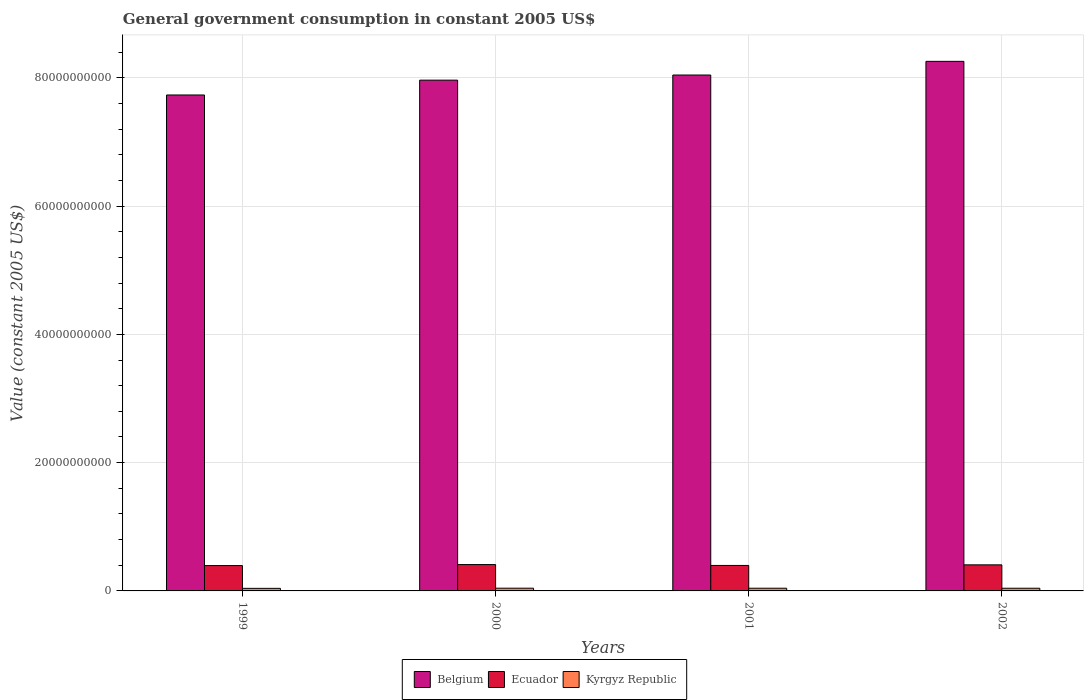How many bars are there on the 1st tick from the left?
Your response must be concise. 3. What is the label of the 2nd group of bars from the left?
Your answer should be very brief. 2000. In how many cases, is the number of bars for a given year not equal to the number of legend labels?
Offer a very short reply. 0. What is the government conusmption in Belgium in 2002?
Provide a short and direct response. 8.26e+1. Across all years, what is the maximum government conusmption in Ecuador?
Keep it short and to the point. 4.11e+09. Across all years, what is the minimum government conusmption in Belgium?
Keep it short and to the point. 7.73e+1. In which year was the government conusmption in Kyrgyz Republic minimum?
Make the answer very short. 1999. What is the total government conusmption in Belgium in the graph?
Provide a succinct answer. 3.20e+11. What is the difference between the government conusmption in Ecuador in 2000 and that in 2002?
Provide a short and direct response. 4.27e+07. What is the difference between the government conusmption in Ecuador in 2000 and the government conusmption in Kyrgyz Republic in 1999?
Give a very brief answer. 3.71e+09. What is the average government conusmption in Belgium per year?
Your answer should be very brief. 8.00e+1. In the year 2000, what is the difference between the government conusmption in Belgium and government conusmption in Ecuador?
Ensure brevity in your answer.  7.55e+1. In how many years, is the government conusmption in Belgium greater than 28000000000 US$?
Your answer should be very brief. 4. What is the ratio of the government conusmption in Belgium in 1999 to that in 2000?
Keep it short and to the point. 0.97. What is the difference between the highest and the second highest government conusmption in Belgium?
Offer a very short reply. 2.13e+09. What is the difference between the highest and the lowest government conusmption in Ecuador?
Your answer should be compact. 1.58e+08. What does the 3rd bar from the left in 1999 represents?
Give a very brief answer. Kyrgyz Republic. What does the 1st bar from the right in 2001 represents?
Provide a short and direct response. Kyrgyz Republic. How many years are there in the graph?
Ensure brevity in your answer.  4. Are the values on the major ticks of Y-axis written in scientific E-notation?
Make the answer very short. No. Does the graph contain any zero values?
Your response must be concise. No. Does the graph contain grids?
Give a very brief answer. Yes. Where does the legend appear in the graph?
Make the answer very short. Bottom center. How many legend labels are there?
Provide a short and direct response. 3. How are the legend labels stacked?
Give a very brief answer. Horizontal. What is the title of the graph?
Your answer should be compact. General government consumption in constant 2005 US$. Does "Heavily indebted poor countries" appear as one of the legend labels in the graph?
Your response must be concise. No. What is the label or title of the Y-axis?
Offer a very short reply. Value (constant 2005 US$). What is the Value (constant 2005 US$) in Belgium in 1999?
Ensure brevity in your answer.  7.73e+1. What is the Value (constant 2005 US$) of Ecuador in 1999?
Offer a very short reply. 3.95e+09. What is the Value (constant 2005 US$) in Kyrgyz Republic in 1999?
Give a very brief answer. 4.01e+08. What is the Value (constant 2005 US$) of Belgium in 2000?
Give a very brief answer. 7.96e+1. What is the Value (constant 2005 US$) in Ecuador in 2000?
Ensure brevity in your answer.  4.11e+09. What is the Value (constant 2005 US$) of Kyrgyz Republic in 2000?
Give a very brief answer. 4.25e+08. What is the Value (constant 2005 US$) of Belgium in 2001?
Your answer should be compact. 8.04e+1. What is the Value (constant 2005 US$) of Ecuador in 2001?
Provide a short and direct response. 3.97e+09. What is the Value (constant 2005 US$) in Kyrgyz Republic in 2001?
Make the answer very short. 4.19e+08. What is the Value (constant 2005 US$) in Belgium in 2002?
Your response must be concise. 8.26e+1. What is the Value (constant 2005 US$) of Ecuador in 2002?
Your answer should be compact. 4.07e+09. What is the Value (constant 2005 US$) of Kyrgyz Republic in 2002?
Provide a short and direct response. 4.18e+08. Across all years, what is the maximum Value (constant 2005 US$) of Belgium?
Your response must be concise. 8.26e+1. Across all years, what is the maximum Value (constant 2005 US$) in Ecuador?
Your response must be concise. 4.11e+09. Across all years, what is the maximum Value (constant 2005 US$) in Kyrgyz Republic?
Give a very brief answer. 4.25e+08. Across all years, what is the minimum Value (constant 2005 US$) of Belgium?
Offer a terse response. 7.73e+1. Across all years, what is the minimum Value (constant 2005 US$) of Ecuador?
Your answer should be compact. 3.95e+09. Across all years, what is the minimum Value (constant 2005 US$) of Kyrgyz Republic?
Provide a short and direct response. 4.01e+08. What is the total Value (constant 2005 US$) in Belgium in the graph?
Offer a very short reply. 3.20e+11. What is the total Value (constant 2005 US$) in Ecuador in the graph?
Your response must be concise. 1.61e+1. What is the total Value (constant 2005 US$) of Kyrgyz Republic in the graph?
Offer a very short reply. 1.66e+09. What is the difference between the Value (constant 2005 US$) in Belgium in 1999 and that in 2000?
Make the answer very short. -2.31e+09. What is the difference between the Value (constant 2005 US$) in Ecuador in 1999 and that in 2000?
Give a very brief answer. -1.58e+08. What is the difference between the Value (constant 2005 US$) in Kyrgyz Republic in 1999 and that in 2000?
Give a very brief answer. -2.38e+07. What is the difference between the Value (constant 2005 US$) of Belgium in 1999 and that in 2001?
Your response must be concise. -3.11e+09. What is the difference between the Value (constant 2005 US$) of Ecuador in 1999 and that in 2001?
Keep it short and to the point. -2.16e+07. What is the difference between the Value (constant 2005 US$) in Kyrgyz Republic in 1999 and that in 2001?
Provide a succinct answer. -1.84e+07. What is the difference between the Value (constant 2005 US$) in Belgium in 1999 and that in 2002?
Keep it short and to the point. -5.24e+09. What is the difference between the Value (constant 2005 US$) in Ecuador in 1999 and that in 2002?
Offer a terse response. -1.15e+08. What is the difference between the Value (constant 2005 US$) of Kyrgyz Republic in 1999 and that in 2002?
Provide a short and direct response. -1.74e+07. What is the difference between the Value (constant 2005 US$) of Belgium in 2000 and that in 2001?
Ensure brevity in your answer.  -8.00e+08. What is the difference between the Value (constant 2005 US$) in Ecuador in 2000 and that in 2001?
Your response must be concise. 1.37e+08. What is the difference between the Value (constant 2005 US$) in Kyrgyz Republic in 2000 and that in 2001?
Offer a very short reply. 5.42e+06. What is the difference between the Value (constant 2005 US$) of Belgium in 2000 and that in 2002?
Your response must be concise. -2.93e+09. What is the difference between the Value (constant 2005 US$) of Ecuador in 2000 and that in 2002?
Provide a succinct answer. 4.27e+07. What is the difference between the Value (constant 2005 US$) of Kyrgyz Republic in 2000 and that in 2002?
Give a very brief answer. 6.35e+06. What is the difference between the Value (constant 2005 US$) of Belgium in 2001 and that in 2002?
Make the answer very short. -2.13e+09. What is the difference between the Value (constant 2005 US$) in Ecuador in 2001 and that in 2002?
Offer a terse response. -9.39e+07. What is the difference between the Value (constant 2005 US$) in Kyrgyz Republic in 2001 and that in 2002?
Your answer should be compact. 9.29e+05. What is the difference between the Value (constant 2005 US$) of Belgium in 1999 and the Value (constant 2005 US$) of Ecuador in 2000?
Make the answer very short. 7.32e+1. What is the difference between the Value (constant 2005 US$) of Belgium in 1999 and the Value (constant 2005 US$) of Kyrgyz Republic in 2000?
Keep it short and to the point. 7.69e+1. What is the difference between the Value (constant 2005 US$) in Ecuador in 1999 and the Value (constant 2005 US$) in Kyrgyz Republic in 2000?
Provide a short and direct response. 3.52e+09. What is the difference between the Value (constant 2005 US$) of Belgium in 1999 and the Value (constant 2005 US$) of Ecuador in 2001?
Provide a short and direct response. 7.34e+1. What is the difference between the Value (constant 2005 US$) of Belgium in 1999 and the Value (constant 2005 US$) of Kyrgyz Republic in 2001?
Offer a very short reply. 7.69e+1. What is the difference between the Value (constant 2005 US$) in Ecuador in 1999 and the Value (constant 2005 US$) in Kyrgyz Republic in 2001?
Offer a terse response. 3.53e+09. What is the difference between the Value (constant 2005 US$) in Belgium in 1999 and the Value (constant 2005 US$) in Ecuador in 2002?
Provide a succinct answer. 7.33e+1. What is the difference between the Value (constant 2005 US$) of Belgium in 1999 and the Value (constant 2005 US$) of Kyrgyz Republic in 2002?
Your answer should be compact. 7.69e+1. What is the difference between the Value (constant 2005 US$) in Ecuador in 1999 and the Value (constant 2005 US$) in Kyrgyz Republic in 2002?
Your response must be concise. 3.53e+09. What is the difference between the Value (constant 2005 US$) in Belgium in 2000 and the Value (constant 2005 US$) in Ecuador in 2001?
Your answer should be very brief. 7.57e+1. What is the difference between the Value (constant 2005 US$) of Belgium in 2000 and the Value (constant 2005 US$) of Kyrgyz Republic in 2001?
Give a very brief answer. 7.92e+1. What is the difference between the Value (constant 2005 US$) of Ecuador in 2000 and the Value (constant 2005 US$) of Kyrgyz Republic in 2001?
Your answer should be compact. 3.69e+09. What is the difference between the Value (constant 2005 US$) of Belgium in 2000 and the Value (constant 2005 US$) of Ecuador in 2002?
Your response must be concise. 7.56e+1. What is the difference between the Value (constant 2005 US$) in Belgium in 2000 and the Value (constant 2005 US$) in Kyrgyz Republic in 2002?
Offer a very short reply. 7.92e+1. What is the difference between the Value (constant 2005 US$) of Ecuador in 2000 and the Value (constant 2005 US$) of Kyrgyz Republic in 2002?
Provide a succinct answer. 3.69e+09. What is the difference between the Value (constant 2005 US$) of Belgium in 2001 and the Value (constant 2005 US$) of Ecuador in 2002?
Keep it short and to the point. 7.64e+1. What is the difference between the Value (constant 2005 US$) of Belgium in 2001 and the Value (constant 2005 US$) of Kyrgyz Republic in 2002?
Make the answer very short. 8.00e+1. What is the difference between the Value (constant 2005 US$) of Ecuador in 2001 and the Value (constant 2005 US$) of Kyrgyz Republic in 2002?
Your answer should be very brief. 3.55e+09. What is the average Value (constant 2005 US$) of Belgium per year?
Your answer should be very brief. 8.00e+1. What is the average Value (constant 2005 US$) of Ecuador per year?
Provide a succinct answer. 4.02e+09. What is the average Value (constant 2005 US$) of Kyrgyz Republic per year?
Keep it short and to the point. 4.16e+08. In the year 1999, what is the difference between the Value (constant 2005 US$) of Belgium and Value (constant 2005 US$) of Ecuador?
Offer a very short reply. 7.34e+1. In the year 1999, what is the difference between the Value (constant 2005 US$) of Belgium and Value (constant 2005 US$) of Kyrgyz Republic?
Ensure brevity in your answer.  7.69e+1. In the year 1999, what is the difference between the Value (constant 2005 US$) in Ecuador and Value (constant 2005 US$) in Kyrgyz Republic?
Give a very brief answer. 3.55e+09. In the year 2000, what is the difference between the Value (constant 2005 US$) in Belgium and Value (constant 2005 US$) in Ecuador?
Your answer should be very brief. 7.55e+1. In the year 2000, what is the difference between the Value (constant 2005 US$) of Belgium and Value (constant 2005 US$) of Kyrgyz Republic?
Offer a very short reply. 7.92e+1. In the year 2000, what is the difference between the Value (constant 2005 US$) of Ecuador and Value (constant 2005 US$) of Kyrgyz Republic?
Ensure brevity in your answer.  3.68e+09. In the year 2001, what is the difference between the Value (constant 2005 US$) of Belgium and Value (constant 2005 US$) of Ecuador?
Provide a short and direct response. 7.65e+1. In the year 2001, what is the difference between the Value (constant 2005 US$) of Belgium and Value (constant 2005 US$) of Kyrgyz Republic?
Offer a very short reply. 8.00e+1. In the year 2001, what is the difference between the Value (constant 2005 US$) of Ecuador and Value (constant 2005 US$) of Kyrgyz Republic?
Ensure brevity in your answer.  3.55e+09. In the year 2002, what is the difference between the Value (constant 2005 US$) in Belgium and Value (constant 2005 US$) in Ecuador?
Provide a succinct answer. 7.85e+1. In the year 2002, what is the difference between the Value (constant 2005 US$) in Belgium and Value (constant 2005 US$) in Kyrgyz Republic?
Offer a terse response. 8.21e+1. In the year 2002, what is the difference between the Value (constant 2005 US$) of Ecuador and Value (constant 2005 US$) of Kyrgyz Republic?
Your response must be concise. 3.65e+09. What is the ratio of the Value (constant 2005 US$) in Belgium in 1999 to that in 2000?
Your answer should be very brief. 0.97. What is the ratio of the Value (constant 2005 US$) of Ecuador in 1999 to that in 2000?
Offer a terse response. 0.96. What is the ratio of the Value (constant 2005 US$) in Kyrgyz Republic in 1999 to that in 2000?
Offer a terse response. 0.94. What is the ratio of the Value (constant 2005 US$) of Belgium in 1999 to that in 2001?
Keep it short and to the point. 0.96. What is the ratio of the Value (constant 2005 US$) of Kyrgyz Republic in 1999 to that in 2001?
Give a very brief answer. 0.96. What is the ratio of the Value (constant 2005 US$) of Belgium in 1999 to that in 2002?
Ensure brevity in your answer.  0.94. What is the ratio of the Value (constant 2005 US$) of Ecuador in 1999 to that in 2002?
Your answer should be very brief. 0.97. What is the ratio of the Value (constant 2005 US$) of Kyrgyz Republic in 1999 to that in 2002?
Provide a succinct answer. 0.96. What is the ratio of the Value (constant 2005 US$) of Ecuador in 2000 to that in 2001?
Ensure brevity in your answer.  1.03. What is the ratio of the Value (constant 2005 US$) of Kyrgyz Republic in 2000 to that in 2001?
Give a very brief answer. 1.01. What is the ratio of the Value (constant 2005 US$) in Belgium in 2000 to that in 2002?
Give a very brief answer. 0.96. What is the ratio of the Value (constant 2005 US$) in Ecuador in 2000 to that in 2002?
Provide a short and direct response. 1.01. What is the ratio of the Value (constant 2005 US$) of Kyrgyz Republic in 2000 to that in 2002?
Keep it short and to the point. 1.02. What is the ratio of the Value (constant 2005 US$) in Belgium in 2001 to that in 2002?
Keep it short and to the point. 0.97. What is the ratio of the Value (constant 2005 US$) of Ecuador in 2001 to that in 2002?
Provide a short and direct response. 0.98. What is the ratio of the Value (constant 2005 US$) in Kyrgyz Republic in 2001 to that in 2002?
Your response must be concise. 1. What is the difference between the highest and the second highest Value (constant 2005 US$) of Belgium?
Your answer should be compact. 2.13e+09. What is the difference between the highest and the second highest Value (constant 2005 US$) of Ecuador?
Give a very brief answer. 4.27e+07. What is the difference between the highest and the second highest Value (constant 2005 US$) of Kyrgyz Republic?
Ensure brevity in your answer.  5.42e+06. What is the difference between the highest and the lowest Value (constant 2005 US$) in Belgium?
Ensure brevity in your answer.  5.24e+09. What is the difference between the highest and the lowest Value (constant 2005 US$) of Ecuador?
Ensure brevity in your answer.  1.58e+08. What is the difference between the highest and the lowest Value (constant 2005 US$) of Kyrgyz Republic?
Give a very brief answer. 2.38e+07. 